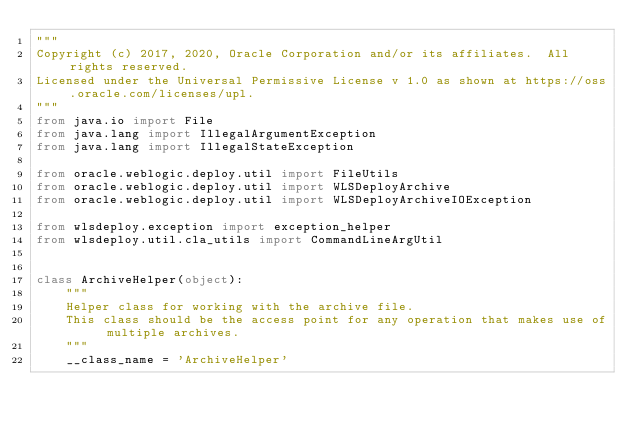<code> <loc_0><loc_0><loc_500><loc_500><_Python_>"""
Copyright (c) 2017, 2020, Oracle Corporation and/or its affiliates.  All rights reserved.
Licensed under the Universal Permissive License v 1.0 as shown at https://oss.oracle.com/licenses/upl.
"""
from java.io import File
from java.lang import IllegalArgumentException
from java.lang import IllegalStateException

from oracle.weblogic.deploy.util import FileUtils
from oracle.weblogic.deploy.util import WLSDeployArchive
from oracle.weblogic.deploy.util import WLSDeployArchiveIOException

from wlsdeploy.exception import exception_helper
from wlsdeploy.util.cla_utils import CommandLineArgUtil


class ArchiveHelper(object):
    """
    Helper class for working with the archive file.
    This class should be the access point for any operation that makes use of multiple archives.
    """
    __class_name = 'ArchiveHelper'
</code> 